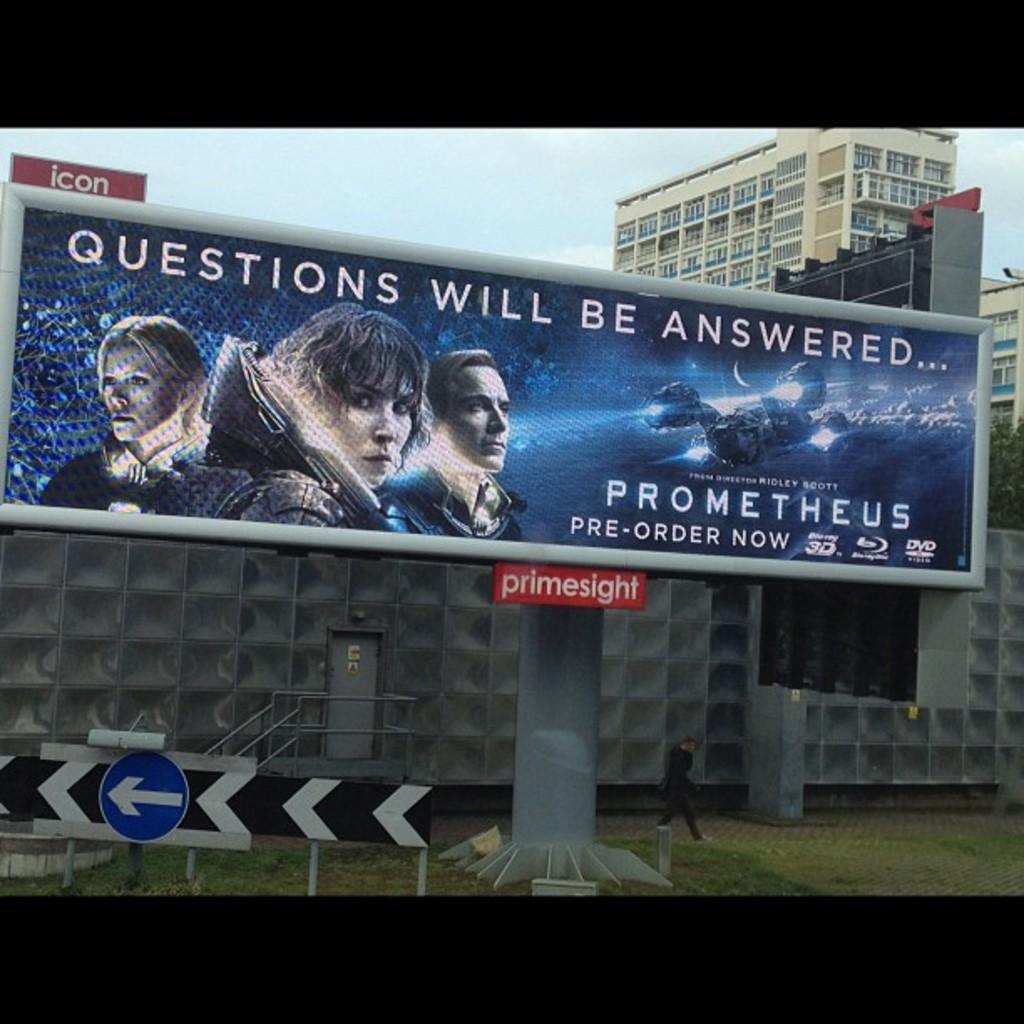<image>
Summarize the visual content of the image. A billboard advertisement for the release of the movie Prometheus. 